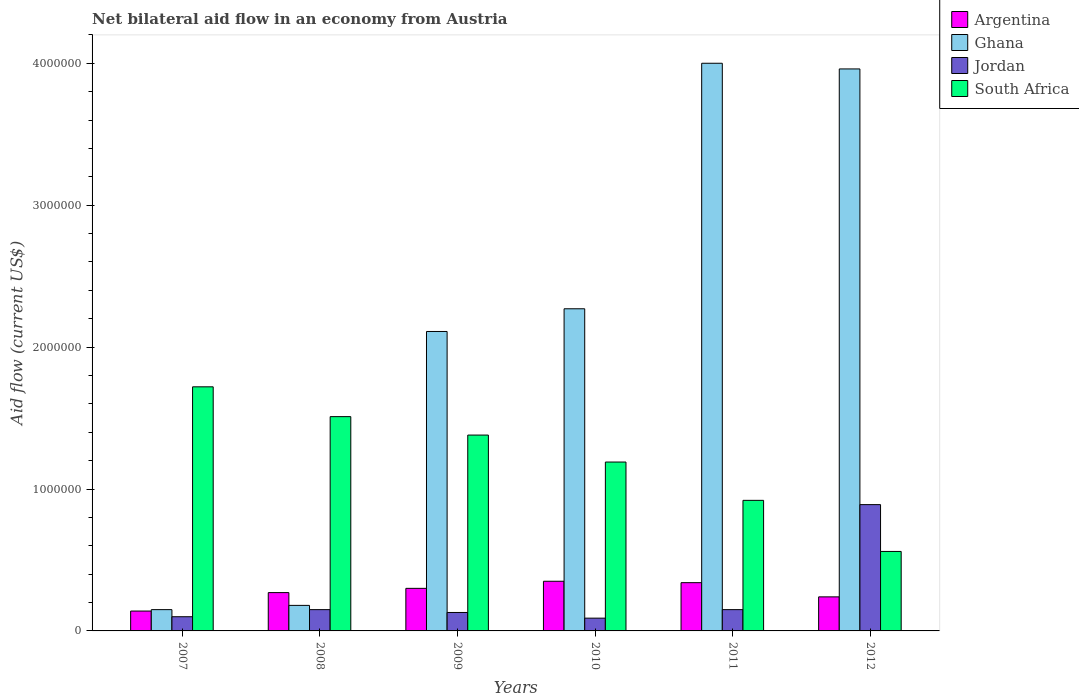How many different coloured bars are there?
Your answer should be compact. 4. How many groups of bars are there?
Ensure brevity in your answer.  6. Are the number of bars on each tick of the X-axis equal?
Provide a short and direct response. Yes. How many bars are there on the 2nd tick from the right?
Offer a very short reply. 4. What is the label of the 3rd group of bars from the left?
Provide a short and direct response. 2009. In how many cases, is the number of bars for a given year not equal to the number of legend labels?
Keep it short and to the point. 0. Across all years, what is the maximum net bilateral aid flow in Ghana?
Ensure brevity in your answer.  4.00e+06. Across all years, what is the minimum net bilateral aid flow in Jordan?
Provide a short and direct response. 9.00e+04. In which year was the net bilateral aid flow in Jordan maximum?
Give a very brief answer. 2012. What is the total net bilateral aid flow in South Africa in the graph?
Your answer should be compact. 7.28e+06. What is the difference between the net bilateral aid flow in South Africa in 2011 and the net bilateral aid flow in Jordan in 2009?
Keep it short and to the point. 7.90e+05. What is the average net bilateral aid flow in South Africa per year?
Provide a succinct answer. 1.21e+06. What is the ratio of the net bilateral aid flow in Argentina in 2007 to that in 2011?
Your answer should be very brief. 0.41. Is the net bilateral aid flow in Jordan in 2010 less than that in 2012?
Your response must be concise. Yes. Is the difference between the net bilateral aid flow in Jordan in 2009 and 2012 greater than the difference between the net bilateral aid flow in Argentina in 2009 and 2012?
Give a very brief answer. No. What is the difference between the highest and the second highest net bilateral aid flow in Ghana?
Ensure brevity in your answer.  4.00e+04. In how many years, is the net bilateral aid flow in Ghana greater than the average net bilateral aid flow in Ghana taken over all years?
Provide a short and direct response. 3. Is it the case that in every year, the sum of the net bilateral aid flow in Ghana and net bilateral aid flow in Argentina is greater than the sum of net bilateral aid flow in Jordan and net bilateral aid flow in South Africa?
Offer a very short reply. No. What does the 4th bar from the left in 2007 represents?
Your answer should be compact. South Africa. Are all the bars in the graph horizontal?
Your answer should be very brief. No. Does the graph contain any zero values?
Your answer should be compact. No. Does the graph contain grids?
Your answer should be compact. No. How many legend labels are there?
Your answer should be compact. 4. How are the legend labels stacked?
Provide a succinct answer. Vertical. What is the title of the graph?
Offer a terse response. Net bilateral aid flow in an economy from Austria. Does "Senegal" appear as one of the legend labels in the graph?
Provide a succinct answer. No. What is the label or title of the X-axis?
Give a very brief answer. Years. What is the label or title of the Y-axis?
Offer a very short reply. Aid flow (current US$). What is the Aid flow (current US$) in Argentina in 2007?
Offer a very short reply. 1.40e+05. What is the Aid flow (current US$) of Ghana in 2007?
Provide a succinct answer. 1.50e+05. What is the Aid flow (current US$) of Jordan in 2007?
Keep it short and to the point. 1.00e+05. What is the Aid flow (current US$) in South Africa in 2007?
Offer a terse response. 1.72e+06. What is the Aid flow (current US$) in Argentina in 2008?
Offer a very short reply. 2.70e+05. What is the Aid flow (current US$) in South Africa in 2008?
Provide a succinct answer. 1.51e+06. What is the Aid flow (current US$) of Ghana in 2009?
Offer a terse response. 2.11e+06. What is the Aid flow (current US$) in Jordan in 2009?
Your answer should be compact. 1.30e+05. What is the Aid flow (current US$) in South Africa in 2009?
Provide a succinct answer. 1.38e+06. What is the Aid flow (current US$) of Argentina in 2010?
Your answer should be compact. 3.50e+05. What is the Aid flow (current US$) in Ghana in 2010?
Offer a terse response. 2.27e+06. What is the Aid flow (current US$) of Jordan in 2010?
Offer a very short reply. 9.00e+04. What is the Aid flow (current US$) of South Africa in 2010?
Your response must be concise. 1.19e+06. What is the Aid flow (current US$) of Ghana in 2011?
Offer a very short reply. 4.00e+06. What is the Aid flow (current US$) of Jordan in 2011?
Your answer should be very brief. 1.50e+05. What is the Aid flow (current US$) in South Africa in 2011?
Your answer should be compact. 9.20e+05. What is the Aid flow (current US$) of Ghana in 2012?
Provide a short and direct response. 3.96e+06. What is the Aid flow (current US$) of Jordan in 2012?
Provide a succinct answer. 8.90e+05. What is the Aid flow (current US$) in South Africa in 2012?
Provide a succinct answer. 5.60e+05. Across all years, what is the maximum Aid flow (current US$) in Argentina?
Provide a succinct answer. 3.50e+05. Across all years, what is the maximum Aid flow (current US$) in Jordan?
Make the answer very short. 8.90e+05. Across all years, what is the maximum Aid flow (current US$) of South Africa?
Give a very brief answer. 1.72e+06. Across all years, what is the minimum Aid flow (current US$) of Ghana?
Keep it short and to the point. 1.50e+05. Across all years, what is the minimum Aid flow (current US$) in South Africa?
Keep it short and to the point. 5.60e+05. What is the total Aid flow (current US$) of Argentina in the graph?
Give a very brief answer. 1.64e+06. What is the total Aid flow (current US$) in Ghana in the graph?
Your answer should be very brief. 1.27e+07. What is the total Aid flow (current US$) of Jordan in the graph?
Ensure brevity in your answer.  1.51e+06. What is the total Aid flow (current US$) of South Africa in the graph?
Keep it short and to the point. 7.28e+06. What is the difference between the Aid flow (current US$) in Argentina in 2007 and that in 2008?
Your response must be concise. -1.30e+05. What is the difference between the Aid flow (current US$) of Ghana in 2007 and that in 2008?
Keep it short and to the point. -3.00e+04. What is the difference between the Aid flow (current US$) in Jordan in 2007 and that in 2008?
Ensure brevity in your answer.  -5.00e+04. What is the difference between the Aid flow (current US$) in Argentina in 2007 and that in 2009?
Offer a very short reply. -1.60e+05. What is the difference between the Aid flow (current US$) of Ghana in 2007 and that in 2009?
Offer a very short reply. -1.96e+06. What is the difference between the Aid flow (current US$) of South Africa in 2007 and that in 2009?
Offer a terse response. 3.40e+05. What is the difference between the Aid flow (current US$) of Argentina in 2007 and that in 2010?
Offer a terse response. -2.10e+05. What is the difference between the Aid flow (current US$) of Ghana in 2007 and that in 2010?
Your response must be concise. -2.12e+06. What is the difference between the Aid flow (current US$) of Jordan in 2007 and that in 2010?
Offer a very short reply. 10000. What is the difference between the Aid flow (current US$) of South Africa in 2007 and that in 2010?
Make the answer very short. 5.30e+05. What is the difference between the Aid flow (current US$) in Ghana in 2007 and that in 2011?
Provide a succinct answer. -3.85e+06. What is the difference between the Aid flow (current US$) of Jordan in 2007 and that in 2011?
Offer a terse response. -5.00e+04. What is the difference between the Aid flow (current US$) in South Africa in 2007 and that in 2011?
Ensure brevity in your answer.  8.00e+05. What is the difference between the Aid flow (current US$) in Ghana in 2007 and that in 2012?
Offer a very short reply. -3.81e+06. What is the difference between the Aid flow (current US$) in Jordan in 2007 and that in 2012?
Offer a terse response. -7.90e+05. What is the difference between the Aid flow (current US$) of South Africa in 2007 and that in 2012?
Offer a terse response. 1.16e+06. What is the difference between the Aid flow (current US$) of Ghana in 2008 and that in 2009?
Make the answer very short. -1.93e+06. What is the difference between the Aid flow (current US$) in Jordan in 2008 and that in 2009?
Keep it short and to the point. 2.00e+04. What is the difference between the Aid flow (current US$) of Ghana in 2008 and that in 2010?
Provide a succinct answer. -2.09e+06. What is the difference between the Aid flow (current US$) of Ghana in 2008 and that in 2011?
Give a very brief answer. -3.82e+06. What is the difference between the Aid flow (current US$) in South Africa in 2008 and that in 2011?
Give a very brief answer. 5.90e+05. What is the difference between the Aid flow (current US$) of Argentina in 2008 and that in 2012?
Make the answer very short. 3.00e+04. What is the difference between the Aid flow (current US$) of Ghana in 2008 and that in 2012?
Provide a succinct answer. -3.78e+06. What is the difference between the Aid flow (current US$) of Jordan in 2008 and that in 2012?
Provide a short and direct response. -7.40e+05. What is the difference between the Aid flow (current US$) in South Africa in 2008 and that in 2012?
Give a very brief answer. 9.50e+05. What is the difference between the Aid flow (current US$) in Jordan in 2009 and that in 2010?
Your answer should be compact. 4.00e+04. What is the difference between the Aid flow (current US$) of Ghana in 2009 and that in 2011?
Provide a short and direct response. -1.89e+06. What is the difference between the Aid flow (current US$) of Ghana in 2009 and that in 2012?
Provide a succinct answer. -1.85e+06. What is the difference between the Aid flow (current US$) of Jordan in 2009 and that in 2012?
Give a very brief answer. -7.60e+05. What is the difference between the Aid flow (current US$) in South Africa in 2009 and that in 2012?
Your response must be concise. 8.20e+05. What is the difference between the Aid flow (current US$) of Ghana in 2010 and that in 2011?
Offer a very short reply. -1.73e+06. What is the difference between the Aid flow (current US$) in Jordan in 2010 and that in 2011?
Your answer should be very brief. -6.00e+04. What is the difference between the Aid flow (current US$) in South Africa in 2010 and that in 2011?
Provide a succinct answer. 2.70e+05. What is the difference between the Aid flow (current US$) of Argentina in 2010 and that in 2012?
Give a very brief answer. 1.10e+05. What is the difference between the Aid flow (current US$) of Ghana in 2010 and that in 2012?
Your answer should be very brief. -1.69e+06. What is the difference between the Aid flow (current US$) of Jordan in 2010 and that in 2012?
Offer a very short reply. -8.00e+05. What is the difference between the Aid flow (current US$) of South Africa in 2010 and that in 2012?
Offer a terse response. 6.30e+05. What is the difference between the Aid flow (current US$) of Argentina in 2011 and that in 2012?
Give a very brief answer. 1.00e+05. What is the difference between the Aid flow (current US$) of Ghana in 2011 and that in 2012?
Your answer should be compact. 4.00e+04. What is the difference between the Aid flow (current US$) in Jordan in 2011 and that in 2012?
Your response must be concise. -7.40e+05. What is the difference between the Aid flow (current US$) of Argentina in 2007 and the Aid flow (current US$) of Ghana in 2008?
Make the answer very short. -4.00e+04. What is the difference between the Aid flow (current US$) in Argentina in 2007 and the Aid flow (current US$) in South Africa in 2008?
Your answer should be compact. -1.37e+06. What is the difference between the Aid flow (current US$) in Ghana in 2007 and the Aid flow (current US$) in Jordan in 2008?
Your answer should be compact. 0. What is the difference between the Aid flow (current US$) of Ghana in 2007 and the Aid flow (current US$) of South Africa in 2008?
Ensure brevity in your answer.  -1.36e+06. What is the difference between the Aid flow (current US$) of Jordan in 2007 and the Aid flow (current US$) of South Africa in 2008?
Your response must be concise. -1.41e+06. What is the difference between the Aid flow (current US$) in Argentina in 2007 and the Aid flow (current US$) in Ghana in 2009?
Offer a terse response. -1.97e+06. What is the difference between the Aid flow (current US$) of Argentina in 2007 and the Aid flow (current US$) of South Africa in 2009?
Your answer should be very brief. -1.24e+06. What is the difference between the Aid flow (current US$) of Ghana in 2007 and the Aid flow (current US$) of South Africa in 2009?
Provide a short and direct response. -1.23e+06. What is the difference between the Aid flow (current US$) of Jordan in 2007 and the Aid flow (current US$) of South Africa in 2009?
Keep it short and to the point. -1.28e+06. What is the difference between the Aid flow (current US$) in Argentina in 2007 and the Aid flow (current US$) in Ghana in 2010?
Your answer should be very brief. -2.13e+06. What is the difference between the Aid flow (current US$) of Argentina in 2007 and the Aid flow (current US$) of South Africa in 2010?
Provide a succinct answer. -1.05e+06. What is the difference between the Aid flow (current US$) in Ghana in 2007 and the Aid flow (current US$) in Jordan in 2010?
Your answer should be compact. 6.00e+04. What is the difference between the Aid flow (current US$) of Ghana in 2007 and the Aid flow (current US$) of South Africa in 2010?
Keep it short and to the point. -1.04e+06. What is the difference between the Aid flow (current US$) of Jordan in 2007 and the Aid flow (current US$) of South Africa in 2010?
Offer a terse response. -1.09e+06. What is the difference between the Aid flow (current US$) in Argentina in 2007 and the Aid flow (current US$) in Ghana in 2011?
Provide a short and direct response. -3.86e+06. What is the difference between the Aid flow (current US$) of Argentina in 2007 and the Aid flow (current US$) of South Africa in 2011?
Give a very brief answer. -7.80e+05. What is the difference between the Aid flow (current US$) of Ghana in 2007 and the Aid flow (current US$) of South Africa in 2011?
Provide a short and direct response. -7.70e+05. What is the difference between the Aid flow (current US$) in Jordan in 2007 and the Aid flow (current US$) in South Africa in 2011?
Offer a terse response. -8.20e+05. What is the difference between the Aid flow (current US$) in Argentina in 2007 and the Aid flow (current US$) in Ghana in 2012?
Keep it short and to the point. -3.82e+06. What is the difference between the Aid flow (current US$) of Argentina in 2007 and the Aid flow (current US$) of Jordan in 2012?
Make the answer very short. -7.50e+05. What is the difference between the Aid flow (current US$) in Argentina in 2007 and the Aid flow (current US$) in South Africa in 2012?
Provide a succinct answer. -4.20e+05. What is the difference between the Aid flow (current US$) in Ghana in 2007 and the Aid flow (current US$) in Jordan in 2012?
Your answer should be compact. -7.40e+05. What is the difference between the Aid flow (current US$) in Ghana in 2007 and the Aid flow (current US$) in South Africa in 2012?
Your answer should be compact. -4.10e+05. What is the difference between the Aid flow (current US$) in Jordan in 2007 and the Aid flow (current US$) in South Africa in 2012?
Your response must be concise. -4.60e+05. What is the difference between the Aid flow (current US$) of Argentina in 2008 and the Aid flow (current US$) of Ghana in 2009?
Your answer should be very brief. -1.84e+06. What is the difference between the Aid flow (current US$) of Argentina in 2008 and the Aid flow (current US$) of Jordan in 2009?
Your response must be concise. 1.40e+05. What is the difference between the Aid flow (current US$) of Argentina in 2008 and the Aid flow (current US$) of South Africa in 2009?
Your answer should be very brief. -1.11e+06. What is the difference between the Aid flow (current US$) in Ghana in 2008 and the Aid flow (current US$) in South Africa in 2009?
Offer a very short reply. -1.20e+06. What is the difference between the Aid flow (current US$) of Jordan in 2008 and the Aid flow (current US$) of South Africa in 2009?
Your answer should be compact. -1.23e+06. What is the difference between the Aid flow (current US$) of Argentina in 2008 and the Aid flow (current US$) of Ghana in 2010?
Offer a terse response. -2.00e+06. What is the difference between the Aid flow (current US$) in Argentina in 2008 and the Aid flow (current US$) in South Africa in 2010?
Offer a very short reply. -9.20e+05. What is the difference between the Aid flow (current US$) of Ghana in 2008 and the Aid flow (current US$) of Jordan in 2010?
Your response must be concise. 9.00e+04. What is the difference between the Aid flow (current US$) of Ghana in 2008 and the Aid flow (current US$) of South Africa in 2010?
Give a very brief answer. -1.01e+06. What is the difference between the Aid flow (current US$) in Jordan in 2008 and the Aid flow (current US$) in South Africa in 2010?
Your response must be concise. -1.04e+06. What is the difference between the Aid flow (current US$) of Argentina in 2008 and the Aid flow (current US$) of Ghana in 2011?
Your answer should be very brief. -3.73e+06. What is the difference between the Aid flow (current US$) of Argentina in 2008 and the Aid flow (current US$) of South Africa in 2011?
Make the answer very short. -6.50e+05. What is the difference between the Aid flow (current US$) in Ghana in 2008 and the Aid flow (current US$) in South Africa in 2011?
Your answer should be compact. -7.40e+05. What is the difference between the Aid flow (current US$) in Jordan in 2008 and the Aid flow (current US$) in South Africa in 2011?
Keep it short and to the point. -7.70e+05. What is the difference between the Aid flow (current US$) of Argentina in 2008 and the Aid flow (current US$) of Ghana in 2012?
Provide a succinct answer. -3.69e+06. What is the difference between the Aid flow (current US$) of Argentina in 2008 and the Aid flow (current US$) of Jordan in 2012?
Make the answer very short. -6.20e+05. What is the difference between the Aid flow (current US$) of Ghana in 2008 and the Aid flow (current US$) of Jordan in 2012?
Your answer should be very brief. -7.10e+05. What is the difference between the Aid flow (current US$) in Ghana in 2008 and the Aid flow (current US$) in South Africa in 2012?
Keep it short and to the point. -3.80e+05. What is the difference between the Aid flow (current US$) in Jordan in 2008 and the Aid flow (current US$) in South Africa in 2012?
Provide a short and direct response. -4.10e+05. What is the difference between the Aid flow (current US$) of Argentina in 2009 and the Aid flow (current US$) of Ghana in 2010?
Keep it short and to the point. -1.97e+06. What is the difference between the Aid flow (current US$) in Argentina in 2009 and the Aid flow (current US$) in Jordan in 2010?
Offer a very short reply. 2.10e+05. What is the difference between the Aid flow (current US$) of Argentina in 2009 and the Aid flow (current US$) of South Africa in 2010?
Provide a succinct answer. -8.90e+05. What is the difference between the Aid flow (current US$) of Ghana in 2009 and the Aid flow (current US$) of Jordan in 2010?
Your response must be concise. 2.02e+06. What is the difference between the Aid flow (current US$) of Ghana in 2009 and the Aid flow (current US$) of South Africa in 2010?
Offer a very short reply. 9.20e+05. What is the difference between the Aid flow (current US$) of Jordan in 2009 and the Aid flow (current US$) of South Africa in 2010?
Provide a short and direct response. -1.06e+06. What is the difference between the Aid flow (current US$) of Argentina in 2009 and the Aid flow (current US$) of Ghana in 2011?
Give a very brief answer. -3.70e+06. What is the difference between the Aid flow (current US$) in Argentina in 2009 and the Aid flow (current US$) in South Africa in 2011?
Offer a terse response. -6.20e+05. What is the difference between the Aid flow (current US$) of Ghana in 2009 and the Aid flow (current US$) of Jordan in 2011?
Keep it short and to the point. 1.96e+06. What is the difference between the Aid flow (current US$) of Ghana in 2009 and the Aid flow (current US$) of South Africa in 2011?
Your response must be concise. 1.19e+06. What is the difference between the Aid flow (current US$) in Jordan in 2009 and the Aid flow (current US$) in South Africa in 2011?
Your answer should be very brief. -7.90e+05. What is the difference between the Aid flow (current US$) of Argentina in 2009 and the Aid flow (current US$) of Ghana in 2012?
Provide a short and direct response. -3.66e+06. What is the difference between the Aid flow (current US$) in Argentina in 2009 and the Aid flow (current US$) in Jordan in 2012?
Give a very brief answer. -5.90e+05. What is the difference between the Aid flow (current US$) in Argentina in 2009 and the Aid flow (current US$) in South Africa in 2012?
Ensure brevity in your answer.  -2.60e+05. What is the difference between the Aid flow (current US$) in Ghana in 2009 and the Aid flow (current US$) in Jordan in 2012?
Provide a succinct answer. 1.22e+06. What is the difference between the Aid flow (current US$) in Ghana in 2009 and the Aid flow (current US$) in South Africa in 2012?
Ensure brevity in your answer.  1.55e+06. What is the difference between the Aid flow (current US$) of Jordan in 2009 and the Aid flow (current US$) of South Africa in 2012?
Your answer should be compact. -4.30e+05. What is the difference between the Aid flow (current US$) of Argentina in 2010 and the Aid flow (current US$) of Ghana in 2011?
Your answer should be compact. -3.65e+06. What is the difference between the Aid flow (current US$) in Argentina in 2010 and the Aid flow (current US$) in South Africa in 2011?
Ensure brevity in your answer.  -5.70e+05. What is the difference between the Aid flow (current US$) of Ghana in 2010 and the Aid flow (current US$) of Jordan in 2011?
Offer a terse response. 2.12e+06. What is the difference between the Aid flow (current US$) in Ghana in 2010 and the Aid flow (current US$) in South Africa in 2011?
Your answer should be very brief. 1.35e+06. What is the difference between the Aid flow (current US$) in Jordan in 2010 and the Aid flow (current US$) in South Africa in 2011?
Your response must be concise. -8.30e+05. What is the difference between the Aid flow (current US$) in Argentina in 2010 and the Aid flow (current US$) in Ghana in 2012?
Your answer should be compact. -3.61e+06. What is the difference between the Aid flow (current US$) in Argentina in 2010 and the Aid flow (current US$) in Jordan in 2012?
Keep it short and to the point. -5.40e+05. What is the difference between the Aid flow (current US$) in Ghana in 2010 and the Aid flow (current US$) in Jordan in 2012?
Keep it short and to the point. 1.38e+06. What is the difference between the Aid flow (current US$) of Ghana in 2010 and the Aid flow (current US$) of South Africa in 2012?
Your answer should be very brief. 1.71e+06. What is the difference between the Aid flow (current US$) in Jordan in 2010 and the Aid flow (current US$) in South Africa in 2012?
Provide a short and direct response. -4.70e+05. What is the difference between the Aid flow (current US$) in Argentina in 2011 and the Aid flow (current US$) in Ghana in 2012?
Offer a terse response. -3.62e+06. What is the difference between the Aid flow (current US$) of Argentina in 2011 and the Aid flow (current US$) of Jordan in 2012?
Provide a short and direct response. -5.50e+05. What is the difference between the Aid flow (current US$) of Argentina in 2011 and the Aid flow (current US$) of South Africa in 2012?
Provide a succinct answer. -2.20e+05. What is the difference between the Aid flow (current US$) of Ghana in 2011 and the Aid flow (current US$) of Jordan in 2012?
Your answer should be very brief. 3.11e+06. What is the difference between the Aid flow (current US$) of Ghana in 2011 and the Aid flow (current US$) of South Africa in 2012?
Offer a terse response. 3.44e+06. What is the difference between the Aid flow (current US$) in Jordan in 2011 and the Aid flow (current US$) in South Africa in 2012?
Provide a short and direct response. -4.10e+05. What is the average Aid flow (current US$) of Argentina per year?
Keep it short and to the point. 2.73e+05. What is the average Aid flow (current US$) in Ghana per year?
Offer a terse response. 2.11e+06. What is the average Aid flow (current US$) of Jordan per year?
Your answer should be very brief. 2.52e+05. What is the average Aid flow (current US$) of South Africa per year?
Your answer should be very brief. 1.21e+06. In the year 2007, what is the difference between the Aid flow (current US$) in Argentina and Aid flow (current US$) in South Africa?
Offer a very short reply. -1.58e+06. In the year 2007, what is the difference between the Aid flow (current US$) in Ghana and Aid flow (current US$) in South Africa?
Keep it short and to the point. -1.57e+06. In the year 2007, what is the difference between the Aid flow (current US$) of Jordan and Aid flow (current US$) of South Africa?
Ensure brevity in your answer.  -1.62e+06. In the year 2008, what is the difference between the Aid flow (current US$) in Argentina and Aid flow (current US$) in Ghana?
Your response must be concise. 9.00e+04. In the year 2008, what is the difference between the Aid flow (current US$) of Argentina and Aid flow (current US$) of South Africa?
Offer a terse response. -1.24e+06. In the year 2008, what is the difference between the Aid flow (current US$) of Ghana and Aid flow (current US$) of Jordan?
Your response must be concise. 3.00e+04. In the year 2008, what is the difference between the Aid flow (current US$) of Ghana and Aid flow (current US$) of South Africa?
Make the answer very short. -1.33e+06. In the year 2008, what is the difference between the Aid flow (current US$) of Jordan and Aid flow (current US$) of South Africa?
Make the answer very short. -1.36e+06. In the year 2009, what is the difference between the Aid flow (current US$) of Argentina and Aid flow (current US$) of Ghana?
Offer a very short reply. -1.81e+06. In the year 2009, what is the difference between the Aid flow (current US$) of Argentina and Aid flow (current US$) of South Africa?
Give a very brief answer. -1.08e+06. In the year 2009, what is the difference between the Aid flow (current US$) of Ghana and Aid flow (current US$) of Jordan?
Your answer should be compact. 1.98e+06. In the year 2009, what is the difference between the Aid flow (current US$) in Ghana and Aid flow (current US$) in South Africa?
Offer a terse response. 7.30e+05. In the year 2009, what is the difference between the Aid flow (current US$) of Jordan and Aid flow (current US$) of South Africa?
Keep it short and to the point. -1.25e+06. In the year 2010, what is the difference between the Aid flow (current US$) of Argentina and Aid flow (current US$) of Ghana?
Provide a short and direct response. -1.92e+06. In the year 2010, what is the difference between the Aid flow (current US$) of Argentina and Aid flow (current US$) of Jordan?
Make the answer very short. 2.60e+05. In the year 2010, what is the difference between the Aid flow (current US$) of Argentina and Aid flow (current US$) of South Africa?
Offer a terse response. -8.40e+05. In the year 2010, what is the difference between the Aid flow (current US$) of Ghana and Aid flow (current US$) of Jordan?
Provide a succinct answer. 2.18e+06. In the year 2010, what is the difference between the Aid flow (current US$) of Ghana and Aid flow (current US$) of South Africa?
Ensure brevity in your answer.  1.08e+06. In the year 2010, what is the difference between the Aid flow (current US$) in Jordan and Aid flow (current US$) in South Africa?
Provide a short and direct response. -1.10e+06. In the year 2011, what is the difference between the Aid flow (current US$) in Argentina and Aid flow (current US$) in Ghana?
Ensure brevity in your answer.  -3.66e+06. In the year 2011, what is the difference between the Aid flow (current US$) of Argentina and Aid flow (current US$) of Jordan?
Give a very brief answer. 1.90e+05. In the year 2011, what is the difference between the Aid flow (current US$) of Argentina and Aid flow (current US$) of South Africa?
Provide a succinct answer. -5.80e+05. In the year 2011, what is the difference between the Aid flow (current US$) of Ghana and Aid flow (current US$) of Jordan?
Ensure brevity in your answer.  3.85e+06. In the year 2011, what is the difference between the Aid flow (current US$) of Ghana and Aid flow (current US$) of South Africa?
Your response must be concise. 3.08e+06. In the year 2011, what is the difference between the Aid flow (current US$) in Jordan and Aid flow (current US$) in South Africa?
Offer a very short reply. -7.70e+05. In the year 2012, what is the difference between the Aid flow (current US$) in Argentina and Aid flow (current US$) in Ghana?
Your answer should be compact. -3.72e+06. In the year 2012, what is the difference between the Aid flow (current US$) in Argentina and Aid flow (current US$) in Jordan?
Your answer should be very brief. -6.50e+05. In the year 2012, what is the difference between the Aid flow (current US$) in Argentina and Aid flow (current US$) in South Africa?
Your response must be concise. -3.20e+05. In the year 2012, what is the difference between the Aid flow (current US$) in Ghana and Aid flow (current US$) in Jordan?
Your answer should be very brief. 3.07e+06. In the year 2012, what is the difference between the Aid flow (current US$) in Ghana and Aid flow (current US$) in South Africa?
Offer a very short reply. 3.40e+06. What is the ratio of the Aid flow (current US$) in Argentina in 2007 to that in 2008?
Keep it short and to the point. 0.52. What is the ratio of the Aid flow (current US$) in Ghana in 2007 to that in 2008?
Give a very brief answer. 0.83. What is the ratio of the Aid flow (current US$) in South Africa in 2007 to that in 2008?
Your answer should be compact. 1.14. What is the ratio of the Aid flow (current US$) in Argentina in 2007 to that in 2009?
Make the answer very short. 0.47. What is the ratio of the Aid flow (current US$) of Ghana in 2007 to that in 2009?
Your response must be concise. 0.07. What is the ratio of the Aid flow (current US$) of Jordan in 2007 to that in 2009?
Your response must be concise. 0.77. What is the ratio of the Aid flow (current US$) in South Africa in 2007 to that in 2009?
Provide a succinct answer. 1.25. What is the ratio of the Aid flow (current US$) in Argentina in 2007 to that in 2010?
Provide a short and direct response. 0.4. What is the ratio of the Aid flow (current US$) of Ghana in 2007 to that in 2010?
Give a very brief answer. 0.07. What is the ratio of the Aid flow (current US$) in Jordan in 2007 to that in 2010?
Provide a succinct answer. 1.11. What is the ratio of the Aid flow (current US$) in South Africa in 2007 to that in 2010?
Your response must be concise. 1.45. What is the ratio of the Aid flow (current US$) in Argentina in 2007 to that in 2011?
Ensure brevity in your answer.  0.41. What is the ratio of the Aid flow (current US$) in Ghana in 2007 to that in 2011?
Offer a very short reply. 0.04. What is the ratio of the Aid flow (current US$) in South Africa in 2007 to that in 2011?
Your response must be concise. 1.87. What is the ratio of the Aid flow (current US$) in Argentina in 2007 to that in 2012?
Ensure brevity in your answer.  0.58. What is the ratio of the Aid flow (current US$) in Ghana in 2007 to that in 2012?
Keep it short and to the point. 0.04. What is the ratio of the Aid flow (current US$) in Jordan in 2007 to that in 2012?
Your answer should be very brief. 0.11. What is the ratio of the Aid flow (current US$) in South Africa in 2007 to that in 2012?
Provide a short and direct response. 3.07. What is the ratio of the Aid flow (current US$) in Ghana in 2008 to that in 2009?
Your response must be concise. 0.09. What is the ratio of the Aid flow (current US$) of Jordan in 2008 to that in 2009?
Your answer should be compact. 1.15. What is the ratio of the Aid flow (current US$) in South Africa in 2008 to that in 2009?
Provide a succinct answer. 1.09. What is the ratio of the Aid flow (current US$) in Argentina in 2008 to that in 2010?
Your answer should be very brief. 0.77. What is the ratio of the Aid flow (current US$) of Ghana in 2008 to that in 2010?
Offer a very short reply. 0.08. What is the ratio of the Aid flow (current US$) in Jordan in 2008 to that in 2010?
Offer a terse response. 1.67. What is the ratio of the Aid flow (current US$) of South Africa in 2008 to that in 2010?
Keep it short and to the point. 1.27. What is the ratio of the Aid flow (current US$) of Argentina in 2008 to that in 2011?
Your answer should be compact. 0.79. What is the ratio of the Aid flow (current US$) in Ghana in 2008 to that in 2011?
Offer a very short reply. 0.04. What is the ratio of the Aid flow (current US$) of South Africa in 2008 to that in 2011?
Your response must be concise. 1.64. What is the ratio of the Aid flow (current US$) in Ghana in 2008 to that in 2012?
Ensure brevity in your answer.  0.05. What is the ratio of the Aid flow (current US$) in Jordan in 2008 to that in 2012?
Your answer should be compact. 0.17. What is the ratio of the Aid flow (current US$) of South Africa in 2008 to that in 2012?
Give a very brief answer. 2.7. What is the ratio of the Aid flow (current US$) in Argentina in 2009 to that in 2010?
Your answer should be very brief. 0.86. What is the ratio of the Aid flow (current US$) in Ghana in 2009 to that in 2010?
Provide a succinct answer. 0.93. What is the ratio of the Aid flow (current US$) in Jordan in 2009 to that in 2010?
Offer a very short reply. 1.44. What is the ratio of the Aid flow (current US$) in South Africa in 2009 to that in 2010?
Offer a very short reply. 1.16. What is the ratio of the Aid flow (current US$) of Argentina in 2009 to that in 2011?
Your answer should be very brief. 0.88. What is the ratio of the Aid flow (current US$) in Ghana in 2009 to that in 2011?
Ensure brevity in your answer.  0.53. What is the ratio of the Aid flow (current US$) in Jordan in 2009 to that in 2011?
Provide a short and direct response. 0.87. What is the ratio of the Aid flow (current US$) of South Africa in 2009 to that in 2011?
Provide a short and direct response. 1.5. What is the ratio of the Aid flow (current US$) of Ghana in 2009 to that in 2012?
Keep it short and to the point. 0.53. What is the ratio of the Aid flow (current US$) in Jordan in 2009 to that in 2012?
Offer a terse response. 0.15. What is the ratio of the Aid flow (current US$) of South Africa in 2009 to that in 2012?
Offer a very short reply. 2.46. What is the ratio of the Aid flow (current US$) of Argentina in 2010 to that in 2011?
Offer a terse response. 1.03. What is the ratio of the Aid flow (current US$) in Ghana in 2010 to that in 2011?
Your answer should be compact. 0.57. What is the ratio of the Aid flow (current US$) of Jordan in 2010 to that in 2011?
Provide a succinct answer. 0.6. What is the ratio of the Aid flow (current US$) in South Africa in 2010 to that in 2011?
Offer a very short reply. 1.29. What is the ratio of the Aid flow (current US$) of Argentina in 2010 to that in 2012?
Offer a very short reply. 1.46. What is the ratio of the Aid flow (current US$) in Ghana in 2010 to that in 2012?
Keep it short and to the point. 0.57. What is the ratio of the Aid flow (current US$) in Jordan in 2010 to that in 2012?
Provide a succinct answer. 0.1. What is the ratio of the Aid flow (current US$) of South Africa in 2010 to that in 2012?
Offer a very short reply. 2.12. What is the ratio of the Aid flow (current US$) of Argentina in 2011 to that in 2012?
Keep it short and to the point. 1.42. What is the ratio of the Aid flow (current US$) of Jordan in 2011 to that in 2012?
Offer a very short reply. 0.17. What is the ratio of the Aid flow (current US$) in South Africa in 2011 to that in 2012?
Offer a terse response. 1.64. What is the difference between the highest and the second highest Aid flow (current US$) of Ghana?
Make the answer very short. 4.00e+04. What is the difference between the highest and the second highest Aid flow (current US$) of Jordan?
Your response must be concise. 7.40e+05. What is the difference between the highest and the lowest Aid flow (current US$) of Ghana?
Ensure brevity in your answer.  3.85e+06. What is the difference between the highest and the lowest Aid flow (current US$) in Jordan?
Ensure brevity in your answer.  8.00e+05. What is the difference between the highest and the lowest Aid flow (current US$) in South Africa?
Provide a succinct answer. 1.16e+06. 